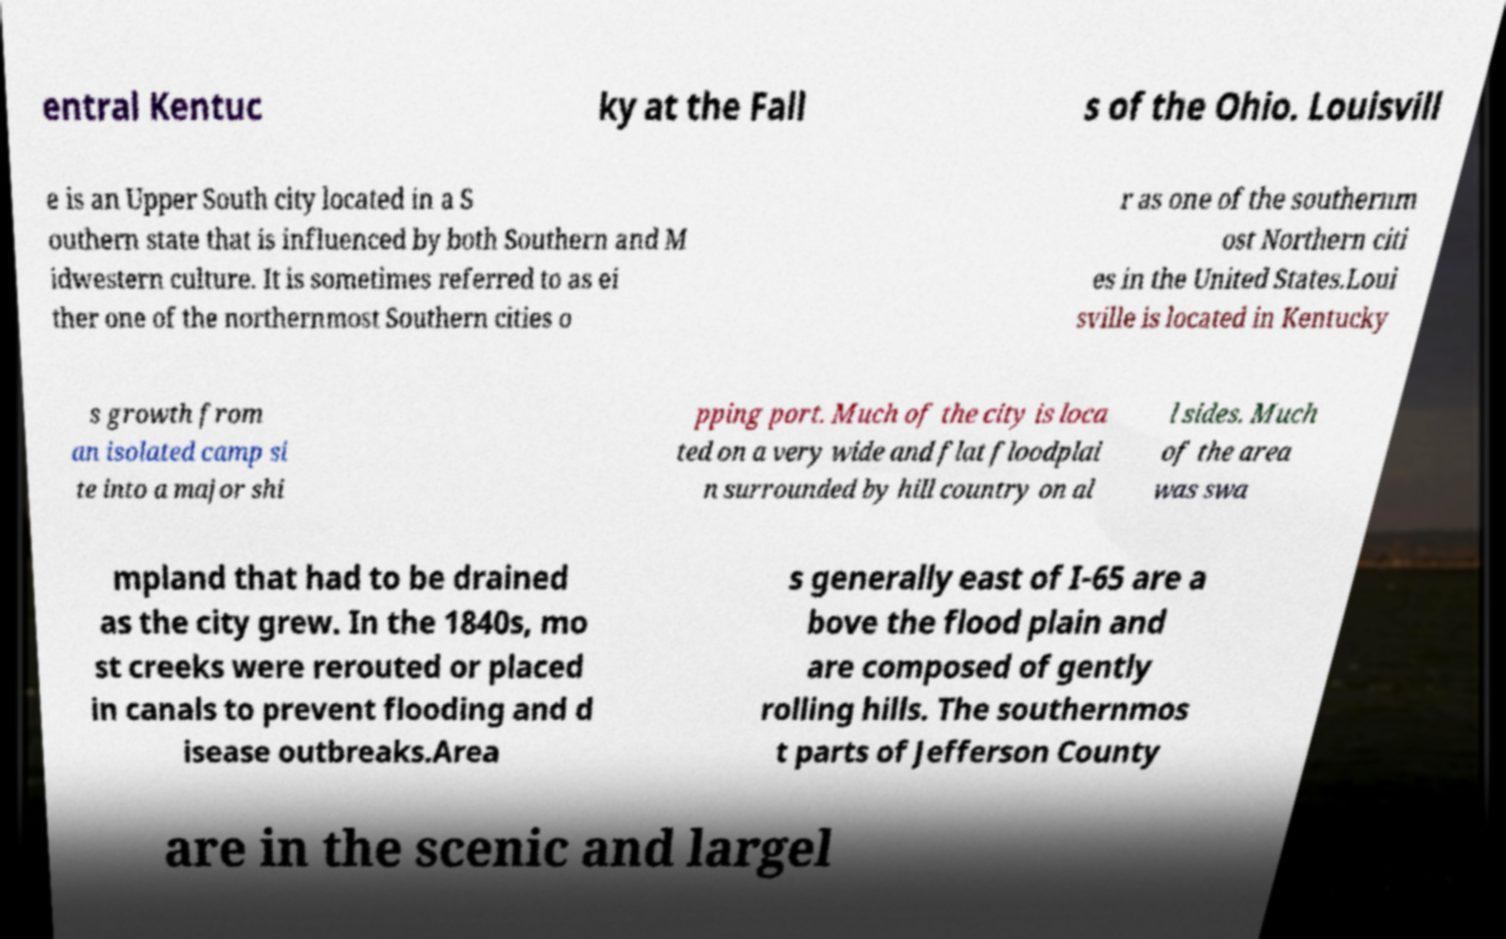Please identify and transcribe the text found in this image. entral Kentuc ky at the Fall s of the Ohio. Louisvill e is an Upper South city located in a S outhern state that is influenced by both Southern and M idwestern culture. It is sometimes referred to as ei ther one of the northernmost Southern cities o r as one of the southernm ost Northern citi es in the United States.Loui sville is located in Kentucky s growth from an isolated camp si te into a major shi pping port. Much of the city is loca ted on a very wide and flat floodplai n surrounded by hill country on al l sides. Much of the area was swa mpland that had to be drained as the city grew. In the 1840s, mo st creeks were rerouted or placed in canals to prevent flooding and d isease outbreaks.Area s generally east of I-65 are a bove the flood plain and are composed of gently rolling hills. The southernmos t parts of Jefferson County are in the scenic and largel 